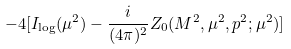<formula> <loc_0><loc_0><loc_500><loc_500>- 4 [ I _ { \log } ( \mu ^ { 2 } ) - \frac { i } { ( 4 \pi ) ^ { 2 } } Z _ { 0 } ( M ^ { 2 } , \mu ^ { 2 } , p ^ { 2 } ; \mu ^ { 2 } ) ]</formula> 